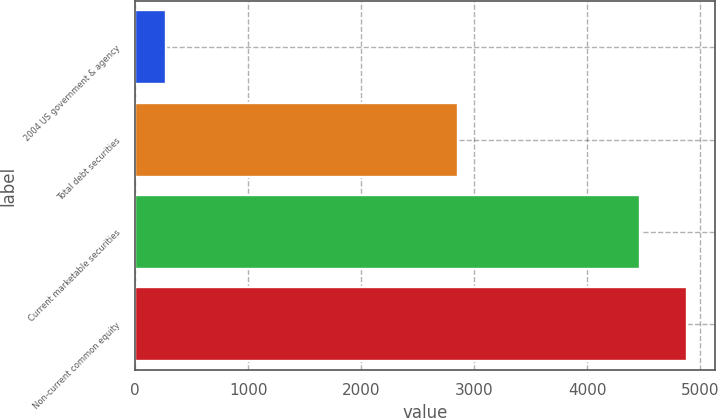Convert chart. <chart><loc_0><loc_0><loc_500><loc_500><bar_chart><fcel>2004 US government & agency<fcel>Total debt securities<fcel>Current marketable securities<fcel>Non-current common equity<nl><fcel>269<fcel>2857<fcel>4466<fcel>4885.7<nl></chart> 